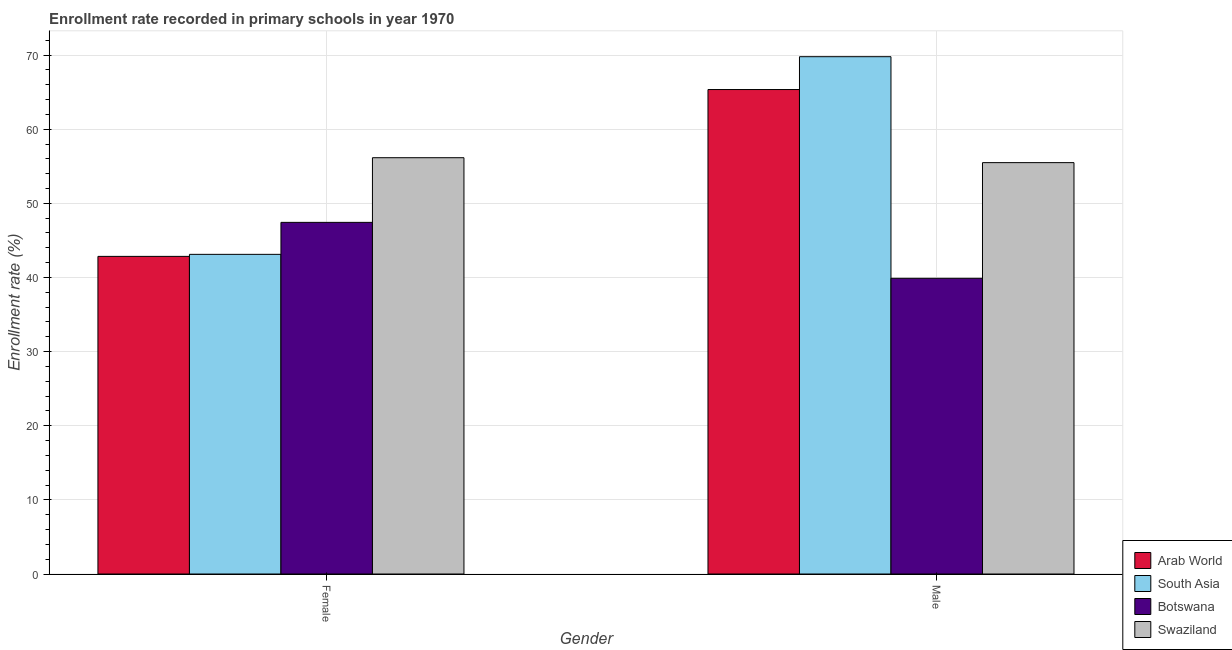How many groups of bars are there?
Provide a succinct answer. 2. Are the number of bars per tick equal to the number of legend labels?
Ensure brevity in your answer.  Yes. Are the number of bars on each tick of the X-axis equal?
Provide a succinct answer. Yes. How many bars are there on the 1st tick from the right?
Offer a very short reply. 4. What is the enrollment rate of female students in South Asia?
Make the answer very short. 43.12. Across all countries, what is the maximum enrollment rate of female students?
Provide a succinct answer. 56.15. Across all countries, what is the minimum enrollment rate of female students?
Your response must be concise. 42.84. In which country was the enrollment rate of female students maximum?
Your answer should be compact. Swaziland. In which country was the enrollment rate of female students minimum?
Your answer should be compact. Arab World. What is the total enrollment rate of male students in the graph?
Keep it short and to the point. 230.5. What is the difference between the enrollment rate of female students in Swaziland and that in Arab World?
Your answer should be compact. 13.31. What is the difference between the enrollment rate of male students in South Asia and the enrollment rate of female students in Swaziland?
Your answer should be very brief. 13.63. What is the average enrollment rate of female students per country?
Your response must be concise. 47.39. What is the difference between the enrollment rate of female students and enrollment rate of male students in Swaziland?
Give a very brief answer. 0.67. In how many countries, is the enrollment rate of female students greater than 52 %?
Provide a short and direct response. 1. What is the ratio of the enrollment rate of female students in South Asia to that in Botswana?
Ensure brevity in your answer.  0.91. Is the enrollment rate of female students in Swaziland less than that in Botswana?
Give a very brief answer. No. In how many countries, is the enrollment rate of female students greater than the average enrollment rate of female students taken over all countries?
Offer a very short reply. 2. What does the 1st bar from the left in Female represents?
Your answer should be compact. Arab World. What does the 3rd bar from the right in Male represents?
Provide a succinct answer. South Asia. How many countries are there in the graph?
Make the answer very short. 4. Does the graph contain any zero values?
Provide a succinct answer. No. Does the graph contain grids?
Ensure brevity in your answer.  Yes. Where does the legend appear in the graph?
Offer a very short reply. Bottom right. How many legend labels are there?
Make the answer very short. 4. What is the title of the graph?
Offer a very short reply. Enrollment rate recorded in primary schools in year 1970. Does "Middle East & North Africa (developing only)" appear as one of the legend labels in the graph?
Keep it short and to the point. No. What is the label or title of the Y-axis?
Your response must be concise. Enrollment rate (%). What is the Enrollment rate (%) of Arab World in Female?
Offer a very short reply. 42.84. What is the Enrollment rate (%) of South Asia in Female?
Offer a very short reply. 43.12. What is the Enrollment rate (%) of Botswana in Female?
Give a very brief answer. 47.43. What is the Enrollment rate (%) of Swaziland in Female?
Ensure brevity in your answer.  56.15. What is the Enrollment rate (%) of Arab World in Male?
Your response must be concise. 65.35. What is the Enrollment rate (%) of South Asia in Male?
Your answer should be compact. 69.78. What is the Enrollment rate (%) of Botswana in Male?
Give a very brief answer. 39.89. What is the Enrollment rate (%) in Swaziland in Male?
Your answer should be compact. 55.49. Across all Gender, what is the maximum Enrollment rate (%) in Arab World?
Provide a succinct answer. 65.35. Across all Gender, what is the maximum Enrollment rate (%) of South Asia?
Your answer should be very brief. 69.78. Across all Gender, what is the maximum Enrollment rate (%) of Botswana?
Keep it short and to the point. 47.43. Across all Gender, what is the maximum Enrollment rate (%) of Swaziland?
Your response must be concise. 56.15. Across all Gender, what is the minimum Enrollment rate (%) of Arab World?
Ensure brevity in your answer.  42.84. Across all Gender, what is the minimum Enrollment rate (%) of South Asia?
Give a very brief answer. 43.12. Across all Gender, what is the minimum Enrollment rate (%) in Botswana?
Give a very brief answer. 39.89. Across all Gender, what is the minimum Enrollment rate (%) in Swaziland?
Provide a succinct answer. 55.49. What is the total Enrollment rate (%) of Arab World in the graph?
Make the answer very short. 108.19. What is the total Enrollment rate (%) in South Asia in the graph?
Give a very brief answer. 112.89. What is the total Enrollment rate (%) of Botswana in the graph?
Your answer should be very brief. 87.31. What is the total Enrollment rate (%) in Swaziland in the graph?
Your response must be concise. 111.64. What is the difference between the Enrollment rate (%) of Arab World in Female and that in Male?
Keep it short and to the point. -22.5. What is the difference between the Enrollment rate (%) in South Asia in Female and that in Male?
Your response must be concise. -26.66. What is the difference between the Enrollment rate (%) of Botswana in Female and that in Male?
Your response must be concise. 7.54. What is the difference between the Enrollment rate (%) in Swaziland in Female and that in Male?
Your answer should be very brief. 0.67. What is the difference between the Enrollment rate (%) of Arab World in Female and the Enrollment rate (%) of South Asia in Male?
Give a very brief answer. -26.93. What is the difference between the Enrollment rate (%) of Arab World in Female and the Enrollment rate (%) of Botswana in Male?
Make the answer very short. 2.96. What is the difference between the Enrollment rate (%) of Arab World in Female and the Enrollment rate (%) of Swaziland in Male?
Keep it short and to the point. -12.64. What is the difference between the Enrollment rate (%) of South Asia in Female and the Enrollment rate (%) of Botswana in Male?
Provide a succinct answer. 3.23. What is the difference between the Enrollment rate (%) of South Asia in Female and the Enrollment rate (%) of Swaziland in Male?
Ensure brevity in your answer.  -12.37. What is the difference between the Enrollment rate (%) of Botswana in Female and the Enrollment rate (%) of Swaziland in Male?
Your answer should be compact. -8.06. What is the average Enrollment rate (%) in Arab World per Gender?
Your answer should be very brief. 54.09. What is the average Enrollment rate (%) of South Asia per Gender?
Provide a short and direct response. 56.45. What is the average Enrollment rate (%) of Botswana per Gender?
Ensure brevity in your answer.  43.66. What is the average Enrollment rate (%) in Swaziland per Gender?
Your answer should be compact. 55.82. What is the difference between the Enrollment rate (%) in Arab World and Enrollment rate (%) in South Asia in Female?
Keep it short and to the point. -0.27. What is the difference between the Enrollment rate (%) of Arab World and Enrollment rate (%) of Botswana in Female?
Make the answer very short. -4.59. What is the difference between the Enrollment rate (%) in Arab World and Enrollment rate (%) in Swaziland in Female?
Ensure brevity in your answer.  -13.31. What is the difference between the Enrollment rate (%) in South Asia and Enrollment rate (%) in Botswana in Female?
Provide a succinct answer. -4.31. What is the difference between the Enrollment rate (%) of South Asia and Enrollment rate (%) of Swaziland in Female?
Offer a very short reply. -13.04. What is the difference between the Enrollment rate (%) of Botswana and Enrollment rate (%) of Swaziland in Female?
Provide a short and direct response. -8.72. What is the difference between the Enrollment rate (%) of Arab World and Enrollment rate (%) of South Asia in Male?
Provide a succinct answer. -4.43. What is the difference between the Enrollment rate (%) of Arab World and Enrollment rate (%) of Botswana in Male?
Your answer should be very brief. 25.46. What is the difference between the Enrollment rate (%) of Arab World and Enrollment rate (%) of Swaziland in Male?
Your response must be concise. 9.86. What is the difference between the Enrollment rate (%) in South Asia and Enrollment rate (%) in Botswana in Male?
Your response must be concise. 29.89. What is the difference between the Enrollment rate (%) of South Asia and Enrollment rate (%) of Swaziland in Male?
Ensure brevity in your answer.  14.29. What is the difference between the Enrollment rate (%) in Botswana and Enrollment rate (%) in Swaziland in Male?
Give a very brief answer. -15.6. What is the ratio of the Enrollment rate (%) in Arab World in Female to that in Male?
Your answer should be compact. 0.66. What is the ratio of the Enrollment rate (%) in South Asia in Female to that in Male?
Your response must be concise. 0.62. What is the ratio of the Enrollment rate (%) of Botswana in Female to that in Male?
Offer a terse response. 1.19. What is the ratio of the Enrollment rate (%) of Swaziland in Female to that in Male?
Give a very brief answer. 1.01. What is the difference between the highest and the second highest Enrollment rate (%) of Arab World?
Your answer should be very brief. 22.5. What is the difference between the highest and the second highest Enrollment rate (%) in South Asia?
Provide a short and direct response. 26.66. What is the difference between the highest and the second highest Enrollment rate (%) of Botswana?
Your answer should be compact. 7.54. What is the difference between the highest and the second highest Enrollment rate (%) of Swaziland?
Make the answer very short. 0.67. What is the difference between the highest and the lowest Enrollment rate (%) in Arab World?
Offer a terse response. 22.5. What is the difference between the highest and the lowest Enrollment rate (%) of South Asia?
Ensure brevity in your answer.  26.66. What is the difference between the highest and the lowest Enrollment rate (%) of Botswana?
Your response must be concise. 7.54. What is the difference between the highest and the lowest Enrollment rate (%) in Swaziland?
Provide a short and direct response. 0.67. 